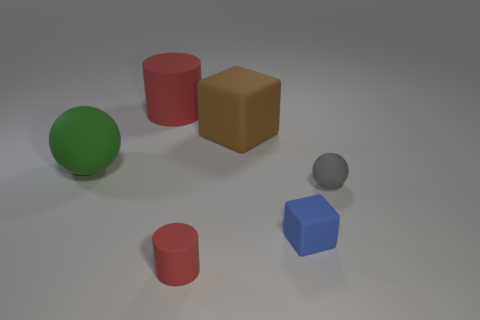Add 4 small blue rubber blocks. How many objects exist? 10 Subtract all balls. How many objects are left? 4 Add 4 small yellow matte things. How many small yellow matte things exist? 4 Subtract 1 blue blocks. How many objects are left? 5 Subtract all brown things. Subtract all brown rubber cubes. How many objects are left? 4 Add 3 green rubber balls. How many green rubber balls are left? 4 